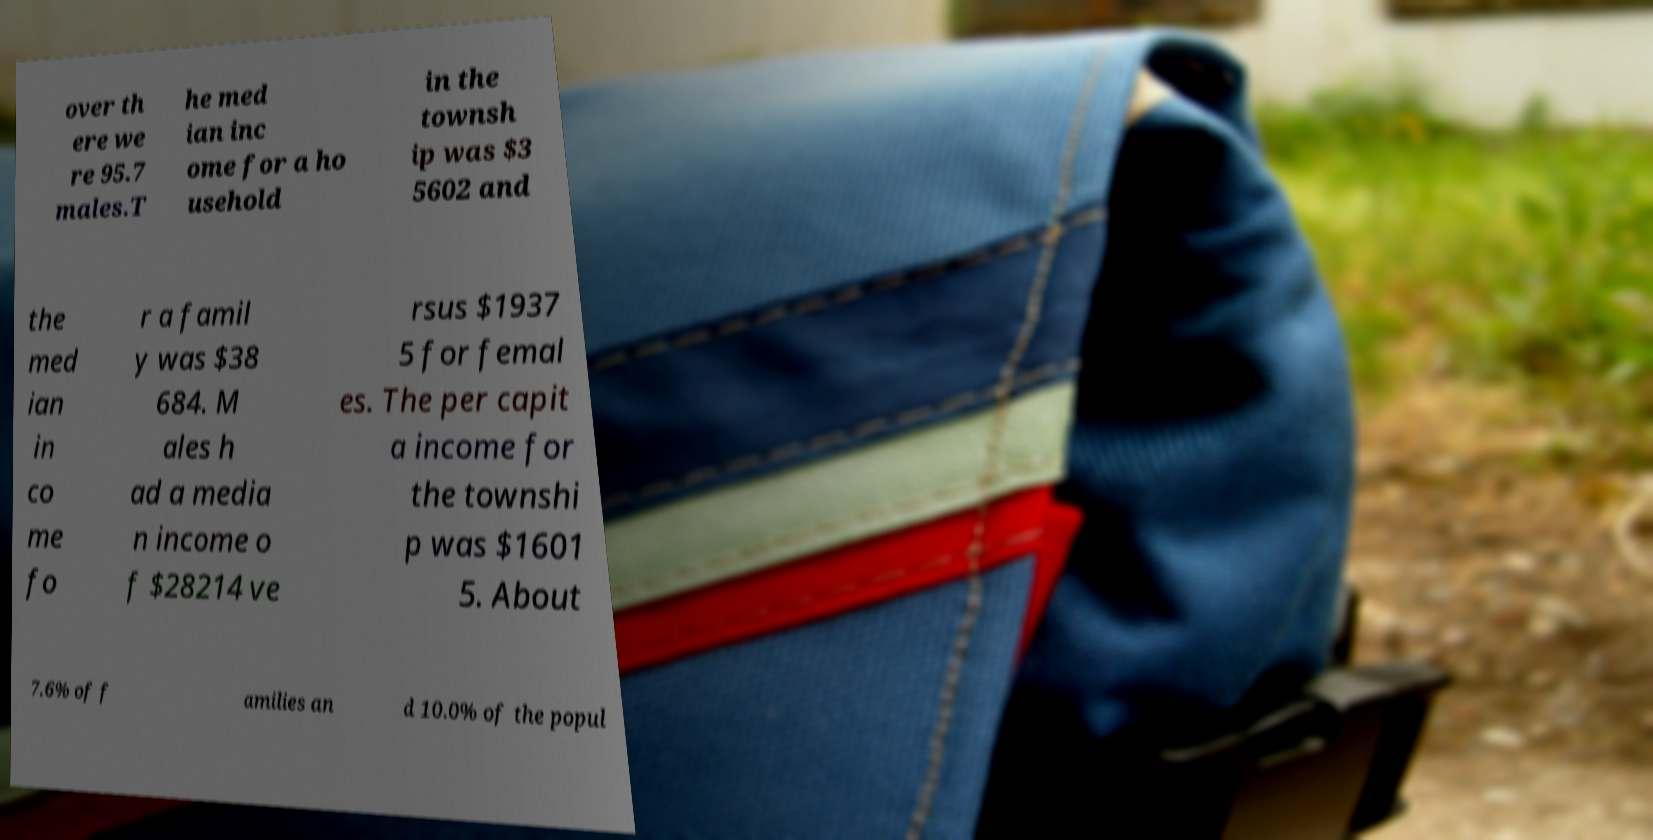What messages or text are displayed in this image? I need them in a readable, typed format. over th ere we re 95.7 males.T he med ian inc ome for a ho usehold in the townsh ip was $3 5602 and the med ian in co me fo r a famil y was $38 684. M ales h ad a media n income o f $28214 ve rsus $1937 5 for femal es. The per capit a income for the townshi p was $1601 5. About 7.6% of f amilies an d 10.0% of the popul 